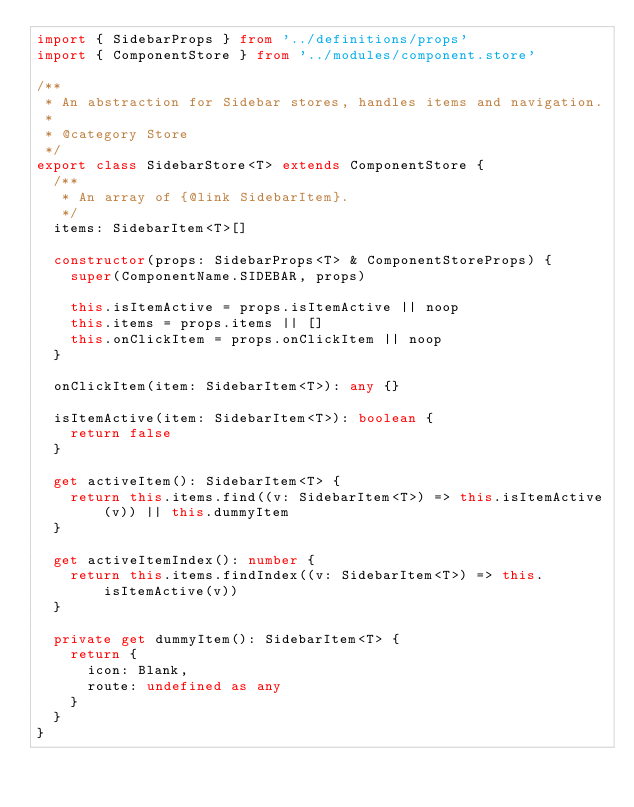Convert code to text. <code><loc_0><loc_0><loc_500><loc_500><_TypeScript_>import { SidebarProps } from '../definitions/props'
import { ComponentStore } from '../modules/component.store'

/**
 * An abstraction for Sidebar stores, handles items and navigation.
 *
 * @category Store
 */
export class SidebarStore<T> extends ComponentStore {
  /**
   * An array of {@link SidebarItem}.
   */
  items: SidebarItem<T>[]

  constructor(props: SidebarProps<T> & ComponentStoreProps) {
    super(ComponentName.SIDEBAR, props)

    this.isItemActive = props.isItemActive || noop
    this.items = props.items || []
    this.onClickItem = props.onClickItem || noop
  }

  onClickItem(item: SidebarItem<T>): any {}

  isItemActive(item: SidebarItem<T>): boolean {
    return false
  }

  get activeItem(): SidebarItem<T> {
    return this.items.find((v: SidebarItem<T>) => this.isItemActive(v)) || this.dummyItem
  }

  get activeItemIndex(): number {
    return this.items.findIndex((v: SidebarItem<T>) => this.isItemActive(v))
  }

  private get dummyItem(): SidebarItem<T> {
    return {
      icon: Blank,
      route: undefined as any
    }
  }
}
</code> 